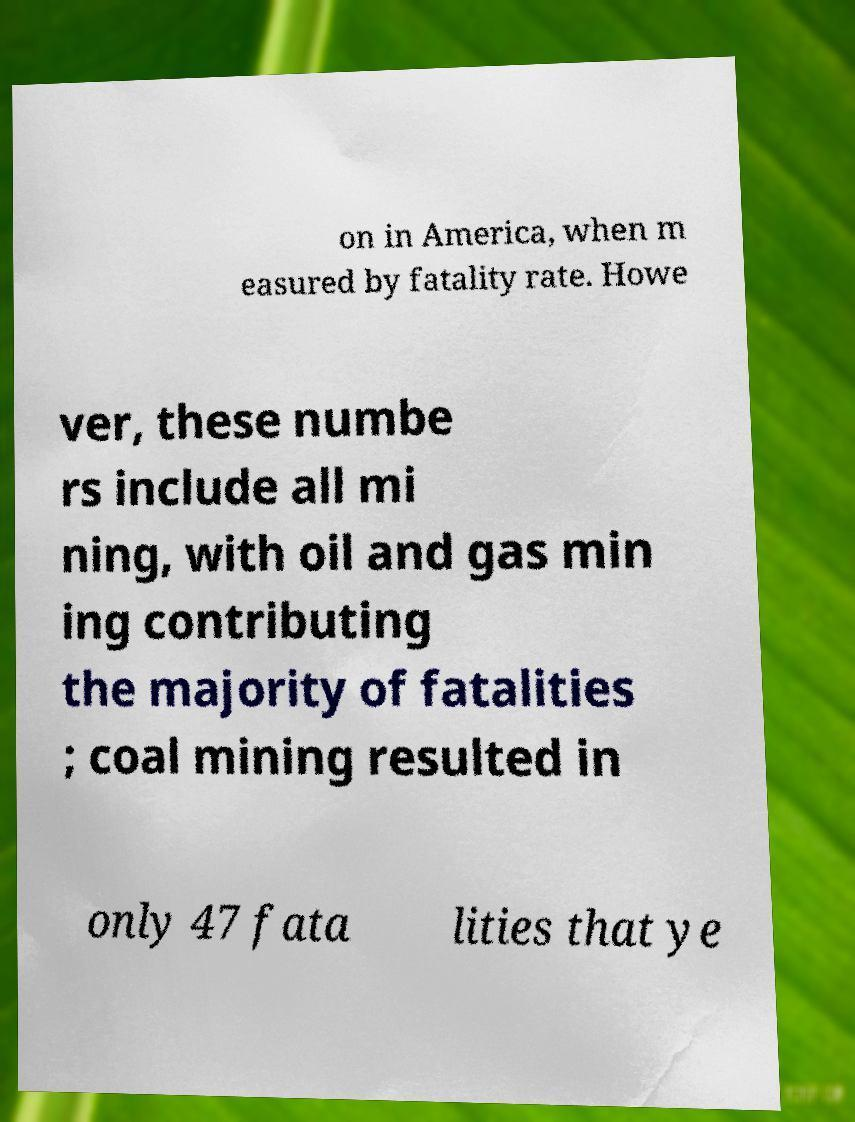Please identify and transcribe the text found in this image. on in America, when m easured by fatality rate. Howe ver, these numbe rs include all mi ning, with oil and gas min ing contributing the majority of fatalities ; coal mining resulted in only 47 fata lities that ye 